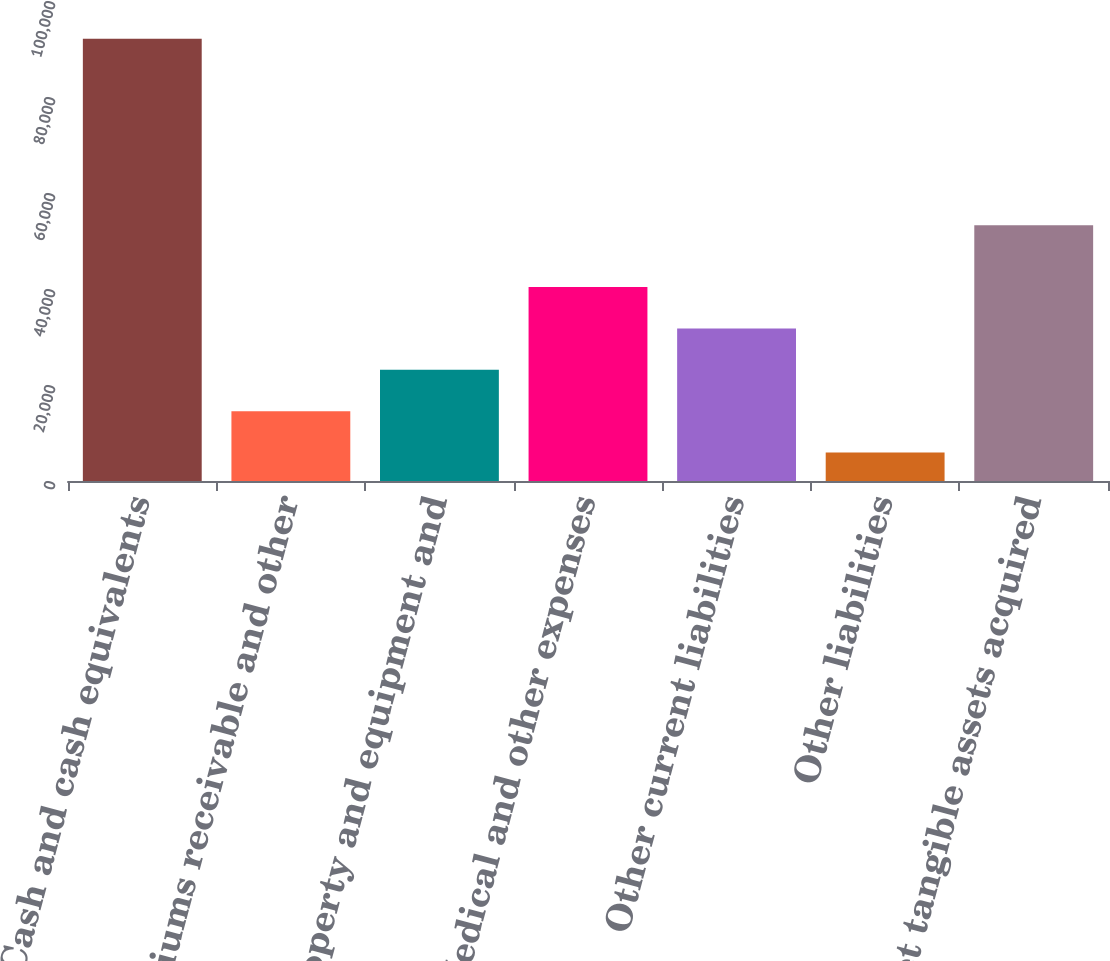<chart> <loc_0><loc_0><loc_500><loc_500><bar_chart><fcel>Cash and cash equivalents<fcel>Premiums receivable and other<fcel>Property and equipment and<fcel>Medical and other expenses<fcel>Other current liabilities<fcel>Other liabilities<fcel>Net tangible assets acquired<nl><fcel>92116<fcel>14535.1<fcel>23155.2<fcel>40395.4<fcel>31775.3<fcel>5915<fcel>53292<nl></chart> 